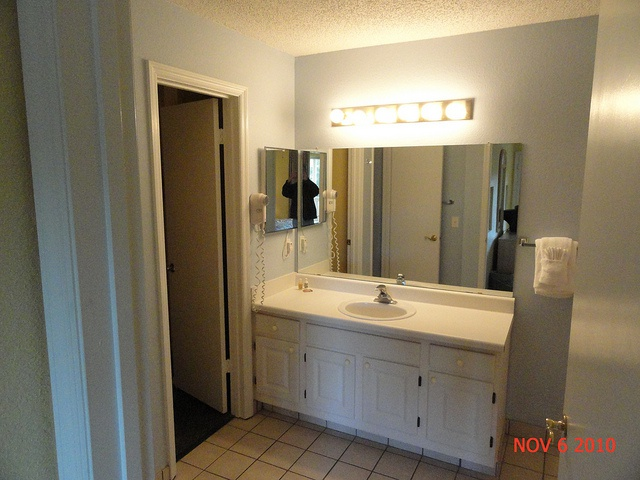Describe the objects in this image and their specific colors. I can see sink in black and tan tones, people in black, gray, and white tones, hair drier in black, gray, tan, and olive tones, hair drier in black, tan, and olive tones, and bottle in black, tan, and olive tones in this image. 